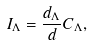<formula> <loc_0><loc_0><loc_500><loc_500>I _ { \Lambda } = \frac { d _ { \Lambda } } { d } C _ { \Lambda } ,</formula> 